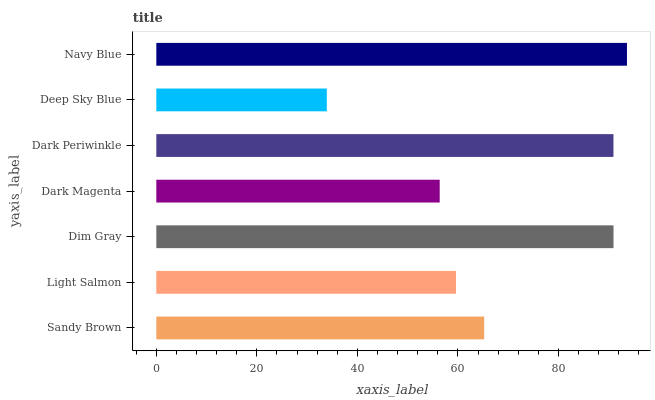Is Deep Sky Blue the minimum?
Answer yes or no. Yes. Is Navy Blue the maximum?
Answer yes or no. Yes. Is Light Salmon the minimum?
Answer yes or no. No. Is Light Salmon the maximum?
Answer yes or no. No. Is Sandy Brown greater than Light Salmon?
Answer yes or no. Yes. Is Light Salmon less than Sandy Brown?
Answer yes or no. Yes. Is Light Salmon greater than Sandy Brown?
Answer yes or no. No. Is Sandy Brown less than Light Salmon?
Answer yes or no. No. Is Sandy Brown the high median?
Answer yes or no. Yes. Is Sandy Brown the low median?
Answer yes or no. Yes. Is Light Salmon the high median?
Answer yes or no. No. Is Navy Blue the low median?
Answer yes or no. No. 